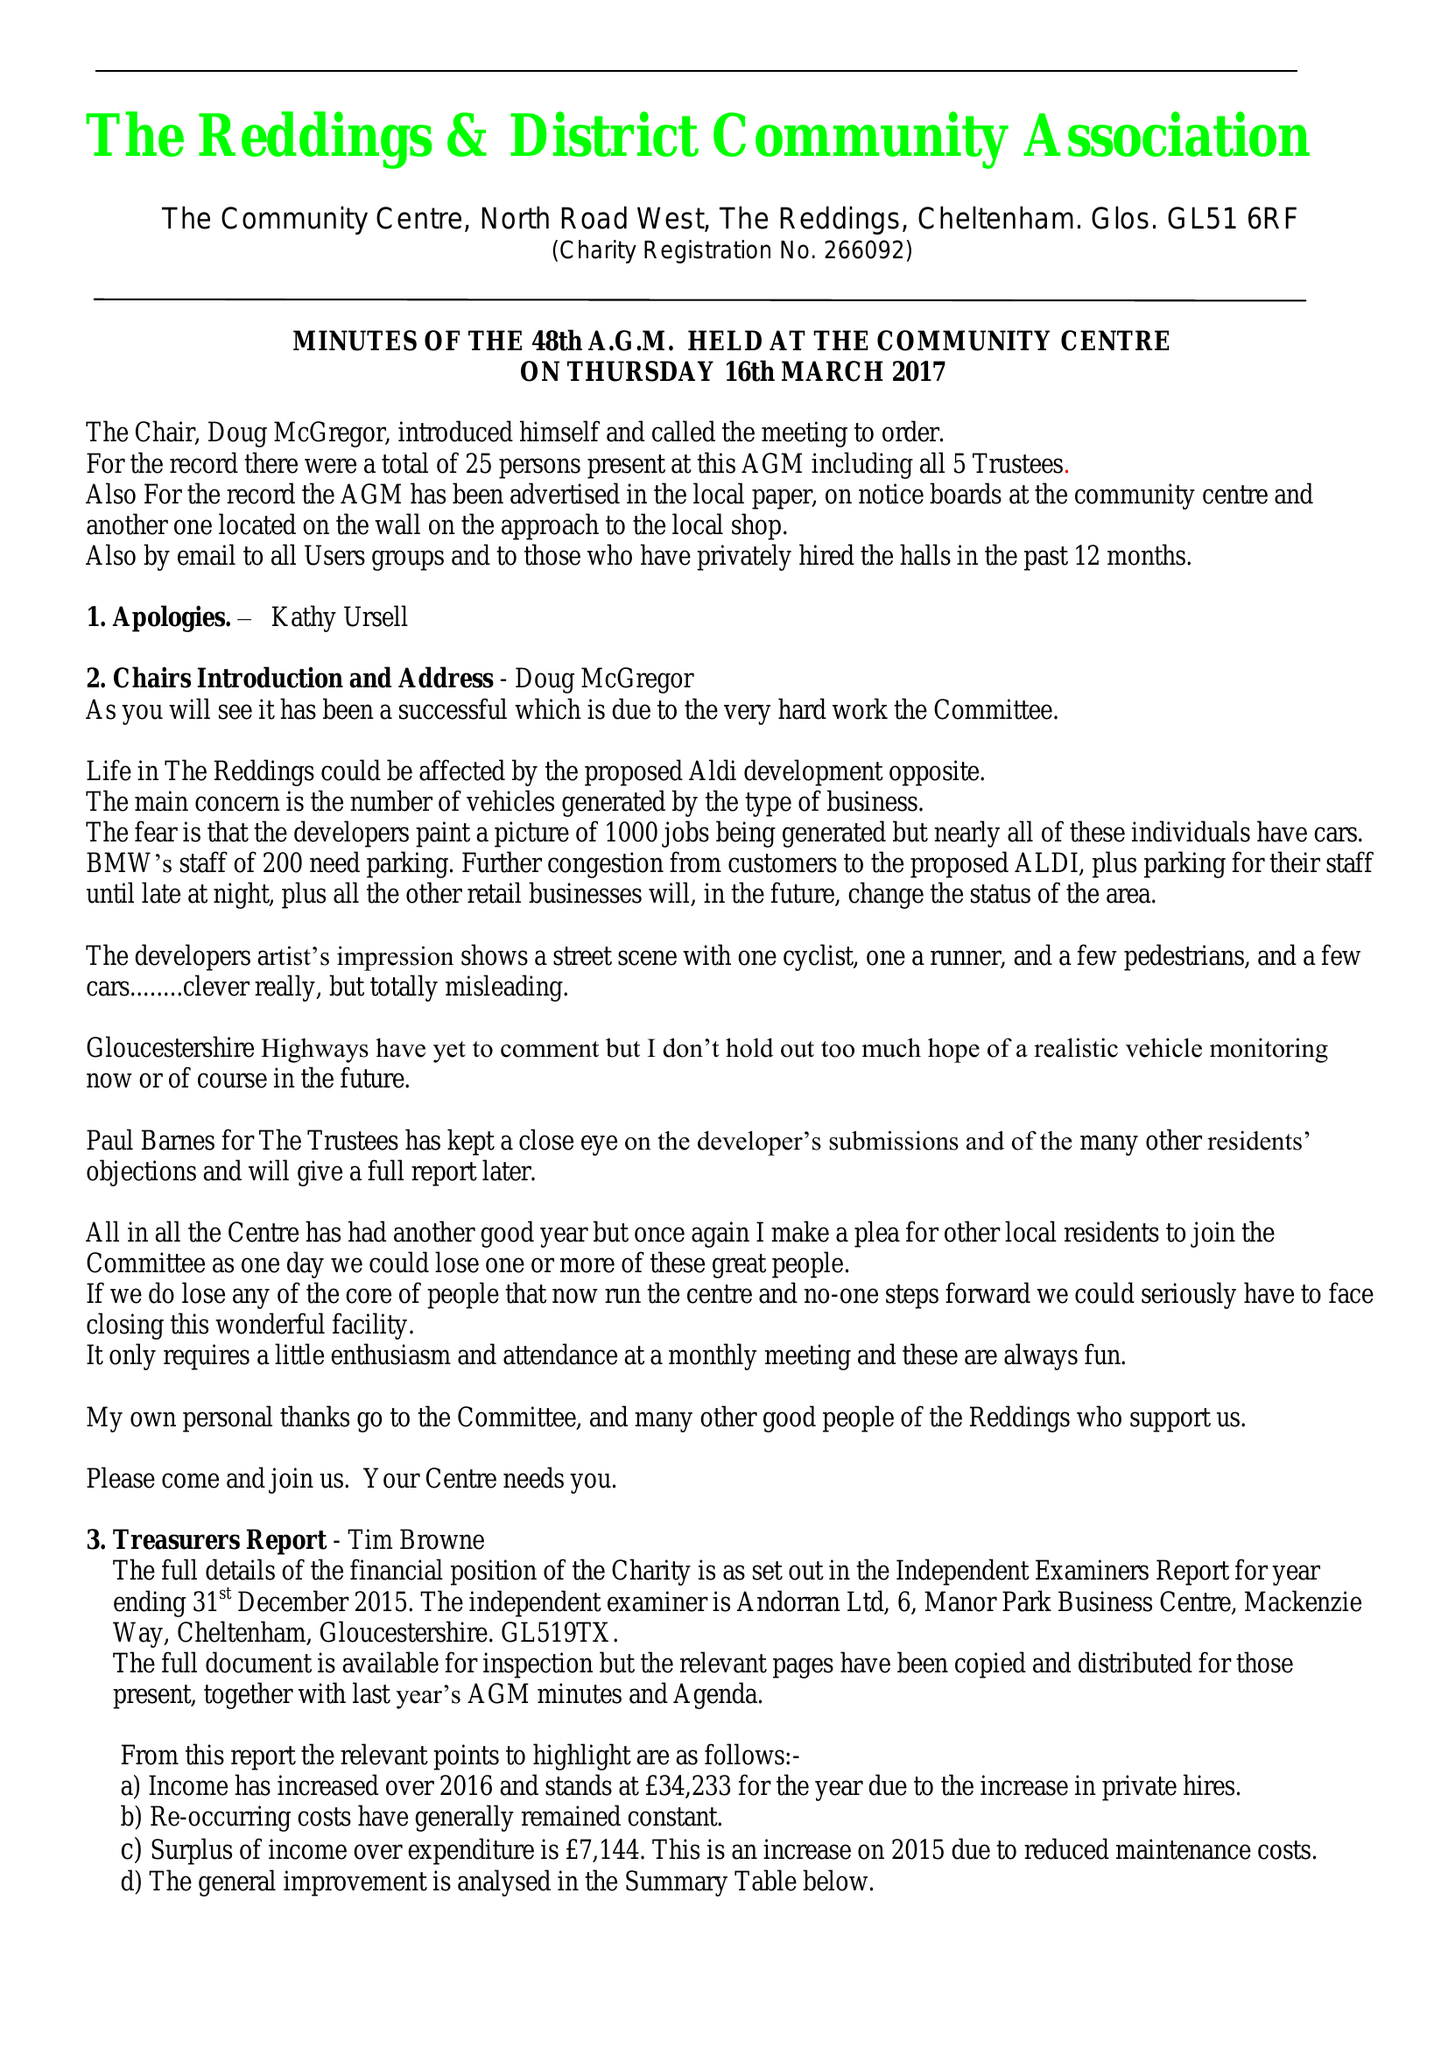What is the value for the charity_name?
Answer the question using a single word or phrase. Reddings and District Community Association 